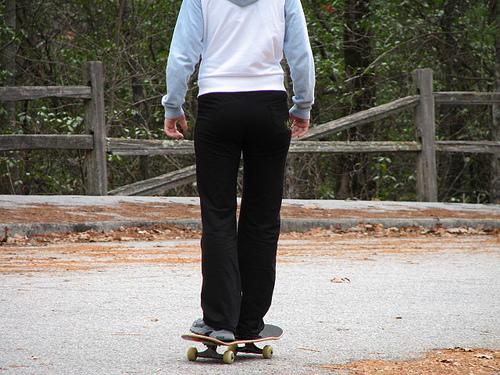What color are the wheels on the board?
Answer briefly. Yellow. Is the fence old or new?
Quick response, please. Old. Did the border break the fence?
Write a very short answer. No. What color is the grass?
Concise answer only. Brown. 